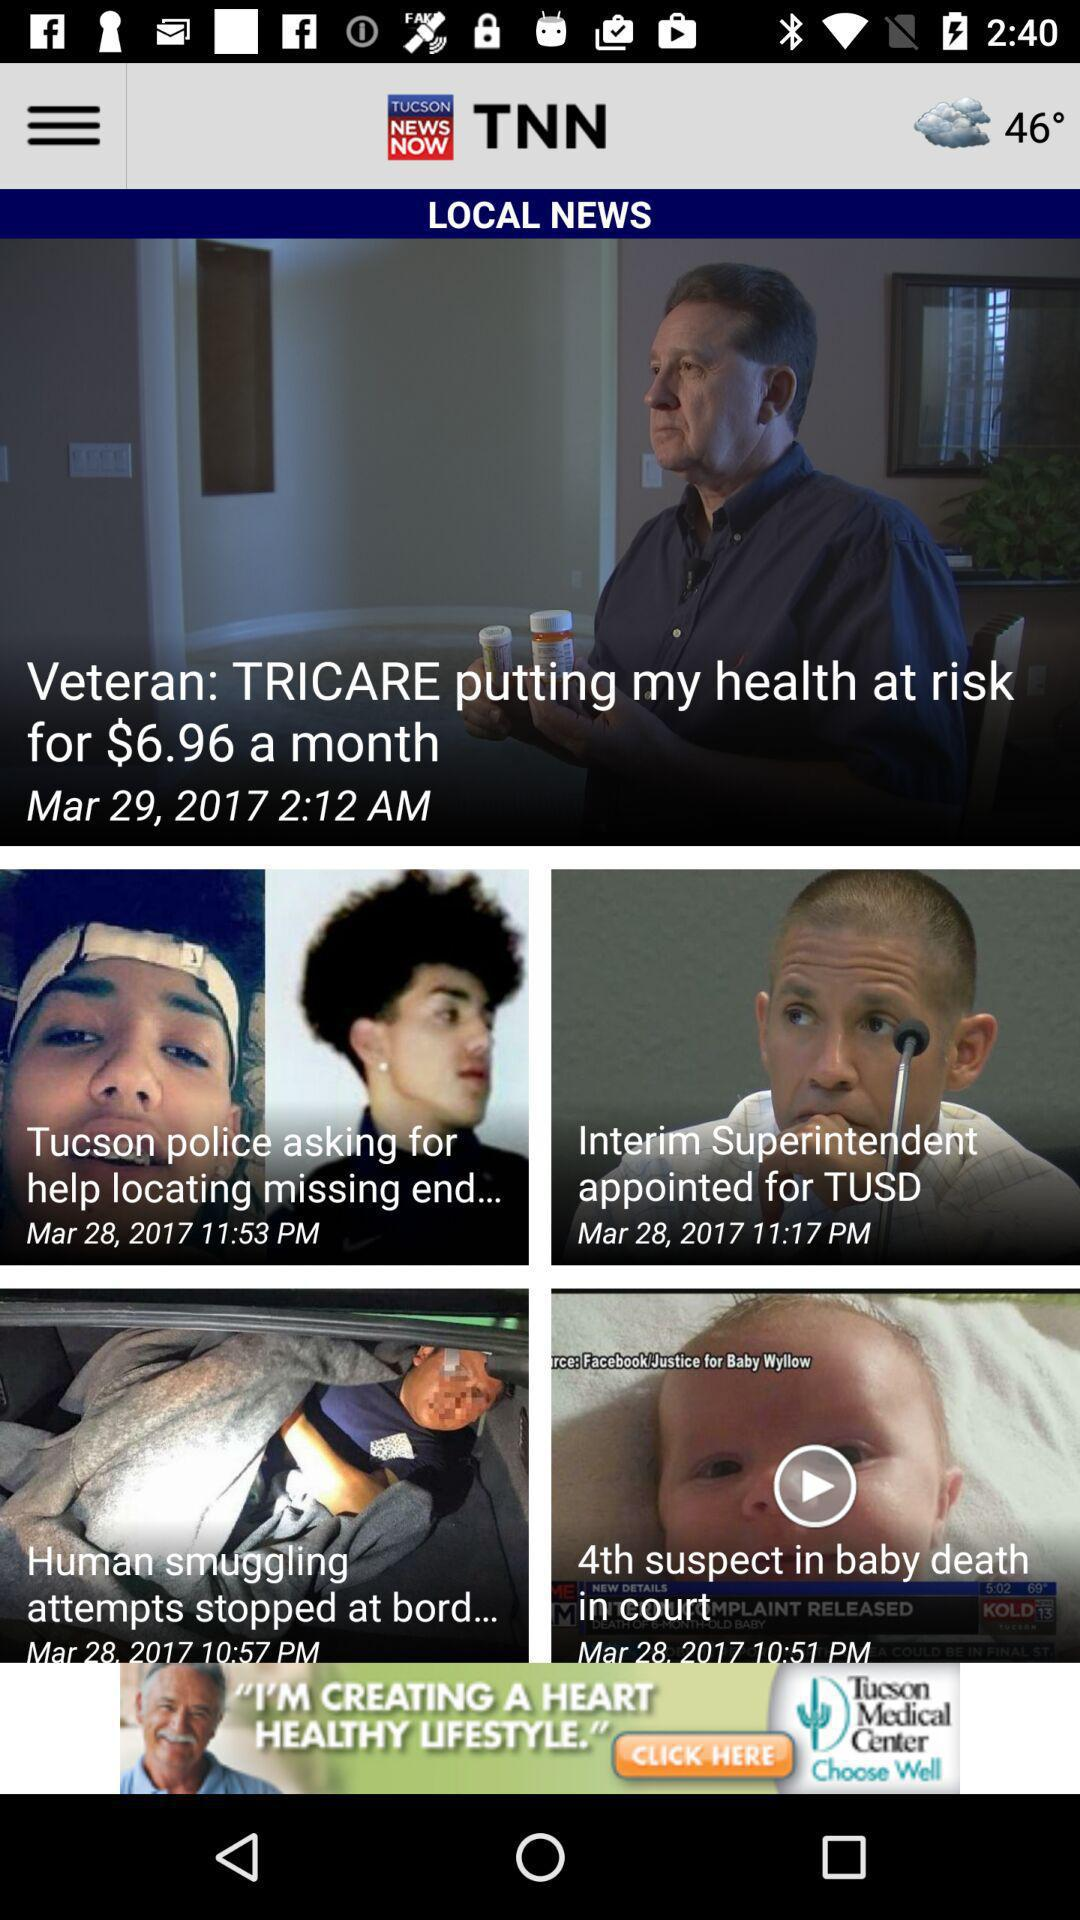When was the "Interim Superintendent appointed for TUSD" news published? The "Interim Superintendent appointed for TUSD" news was published on March 28, 2017 at 11:17 PM. 